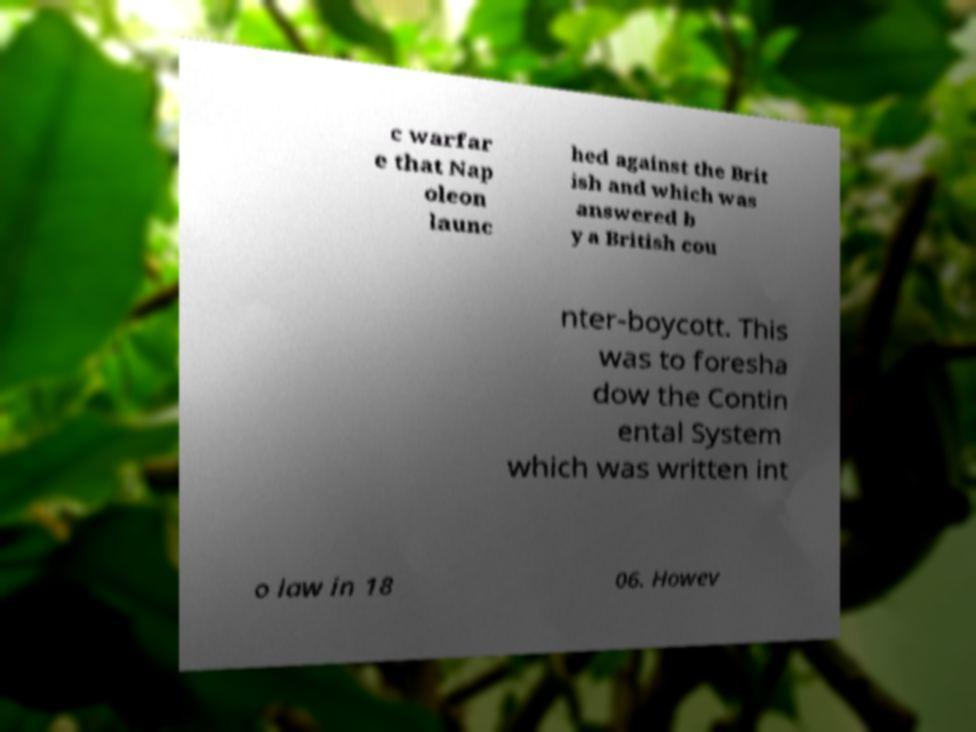I need the written content from this picture converted into text. Can you do that? c warfar e that Nap oleon launc hed against the Brit ish and which was answered b y a British cou nter-boycott. This was to foresha dow the Contin ental System which was written int o law in 18 06. Howev 